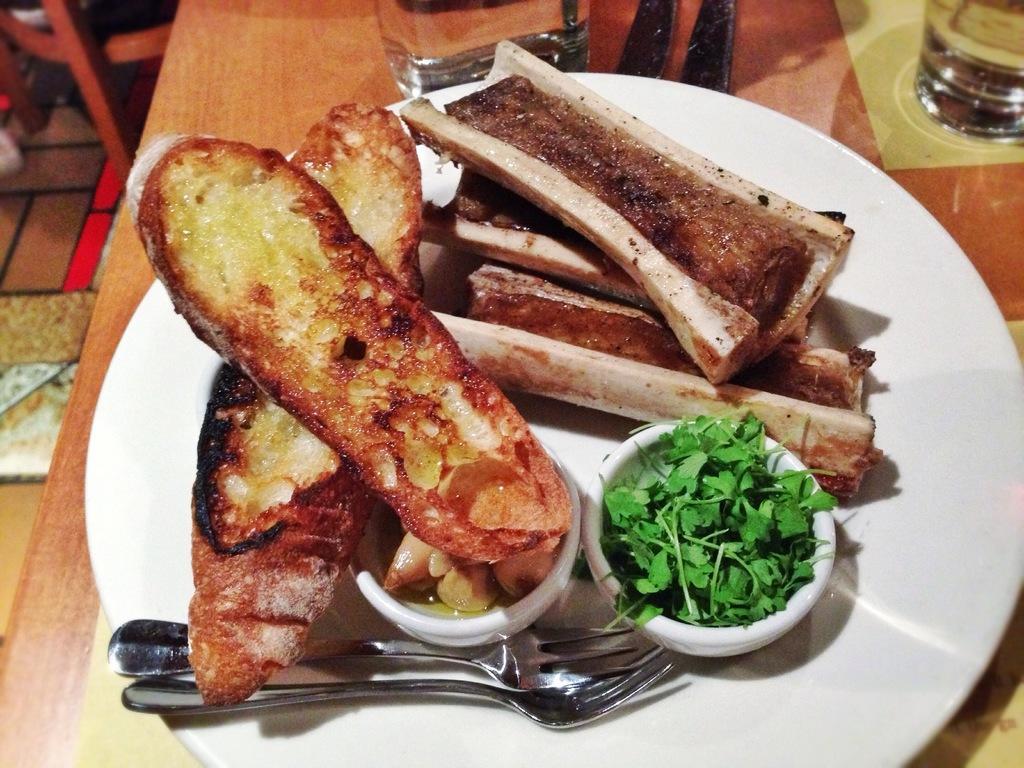Please provide a concise description of this image. In this image there is a table. On the table there is a plate. On that plate there are food items, Vegetable, Spoons and Box. And on the floor there is a chair. 